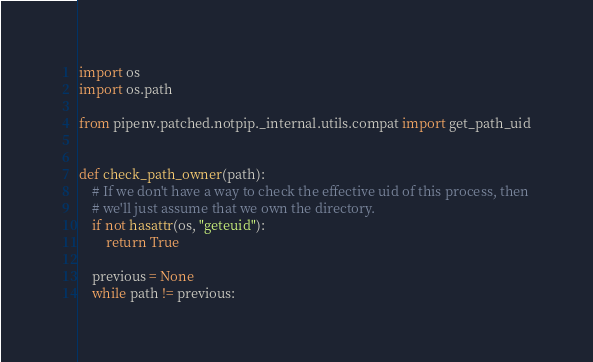Convert code to text. <code><loc_0><loc_0><loc_500><loc_500><_Python_>import os
import os.path

from pipenv.patched.notpip._internal.utils.compat import get_path_uid


def check_path_owner(path):
    # If we don't have a way to check the effective uid of this process, then
    # we'll just assume that we own the directory.
    if not hasattr(os, "geteuid"):
        return True

    previous = None
    while path != previous:</code> 